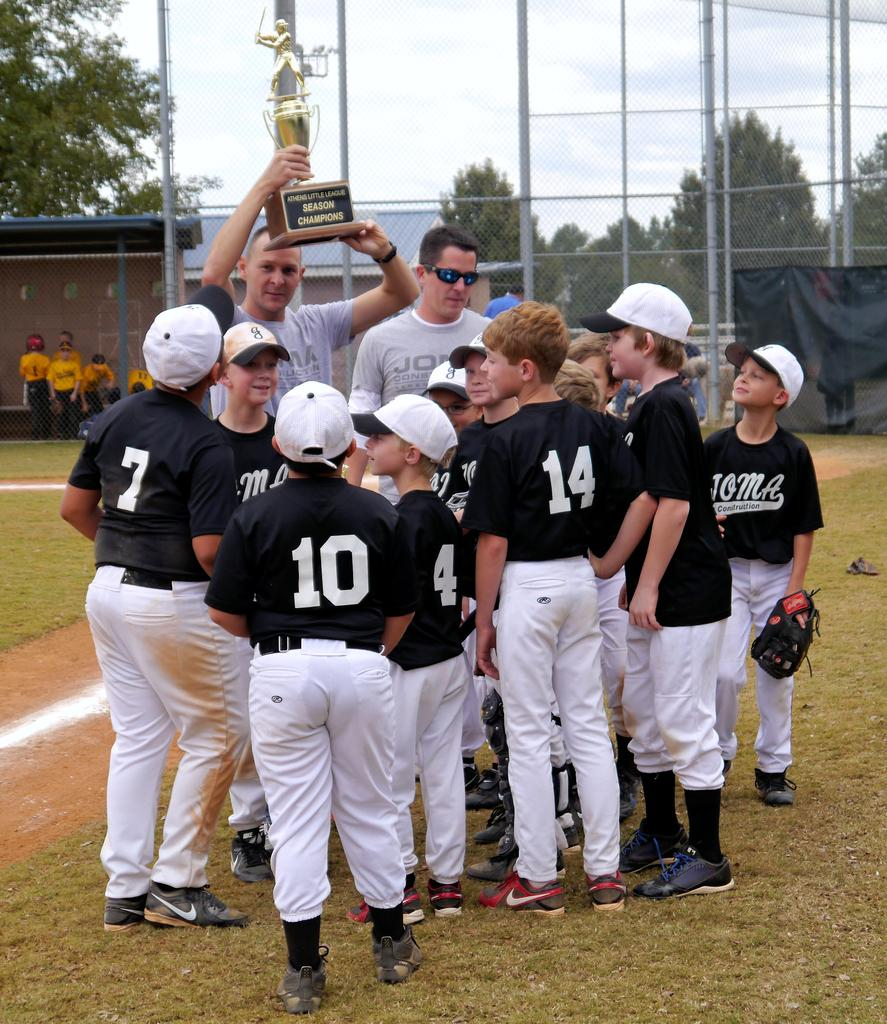<image>
Summarize the visual content of the image. A team of players, one of which is number 10, gathers around their coach. 